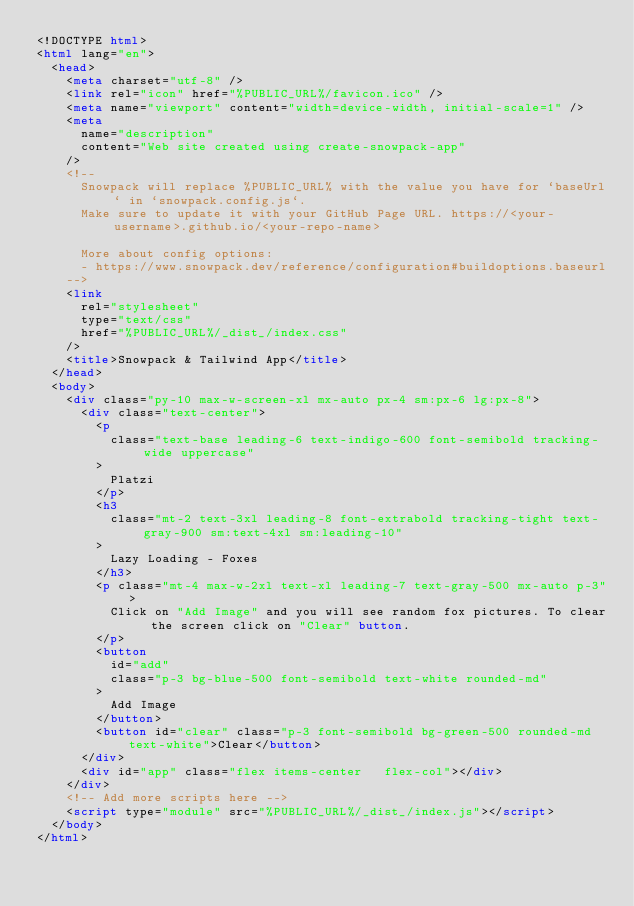<code> <loc_0><loc_0><loc_500><loc_500><_HTML_><!DOCTYPE html>
<html lang="en">
  <head>
    <meta charset="utf-8" />
    <link rel="icon" href="%PUBLIC_URL%/favicon.ico" />
    <meta name="viewport" content="width=device-width, initial-scale=1" />
    <meta
      name="description"
      content="Web site created using create-snowpack-app"
    />
    <!--
      Snowpack will replace %PUBLIC_URL% with the value you have for `baseUrl` in `snowpack.config.js`.
      Make sure to update it with your GitHub Page URL. https://<your-username>.github.io/<your-repo-name>

      More about config options:
      - https://www.snowpack.dev/reference/configuration#buildoptions.baseurl
    -->
    <link
      rel="stylesheet"
      type="text/css"
      href="%PUBLIC_URL%/_dist_/index.css"
    />
    <title>Snowpack & Tailwind App</title>
  </head>
  <body>
    <div class="py-10 max-w-screen-xl mx-auto px-4 sm:px-6 lg:px-8">
      <div class="text-center">
        <p
          class="text-base leading-6 text-indigo-600 font-semibold tracking-wide uppercase"
        >
          Platzi
        </p>
        <h3
          class="mt-2 text-3xl leading-8 font-extrabold tracking-tight text-gray-900 sm:text-4xl sm:leading-10"
        >
          Lazy Loading - Foxes
        </h3>
        <p class="mt-4 max-w-2xl text-xl leading-7 text-gray-500 mx-auto p-3">
          Click on "Add Image" and you will see random fox pictures. To clear the screen click on "Clear" button.
        </p>
        <button 
          id="add"
          class="p-3 bg-blue-500 font-semibold text-white rounded-md"
        >
          Add Image
        </button>
        <button id="clear" class="p-3 font-semibold bg-green-500 rounded-md text-white">Clear</button>
      </div>
      <div id="app" class="flex items-center	 flex-col"></div>
    </div>
    <!-- Add more scripts here -->
    <script type="module" src="%PUBLIC_URL%/_dist_/index.js"></script>
  </body>
</html>
</code> 